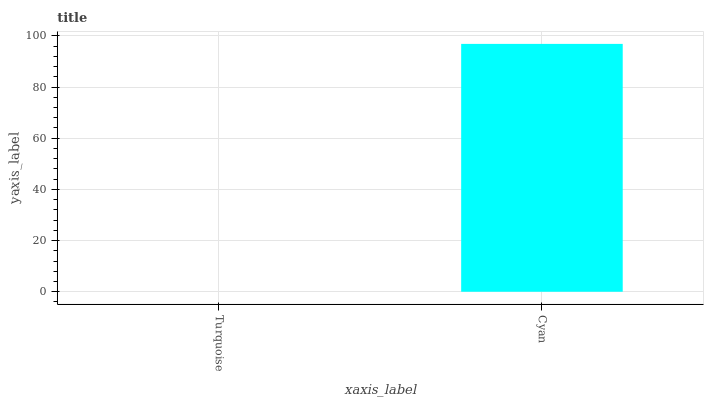Is Turquoise the minimum?
Answer yes or no. Yes. Is Cyan the maximum?
Answer yes or no. Yes. Is Cyan the minimum?
Answer yes or no. No. Is Cyan greater than Turquoise?
Answer yes or no. Yes. Is Turquoise less than Cyan?
Answer yes or no. Yes. Is Turquoise greater than Cyan?
Answer yes or no. No. Is Cyan less than Turquoise?
Answer yes or no. No. Is Cyan the high median?
Answer yes or no. Yes. Is Turquoise the low median?
Answer yes or no. Yes. Is Turquoise the high median?
Answer yes or no. No. Is Cyan the low median?
Answer yes or no. No. 